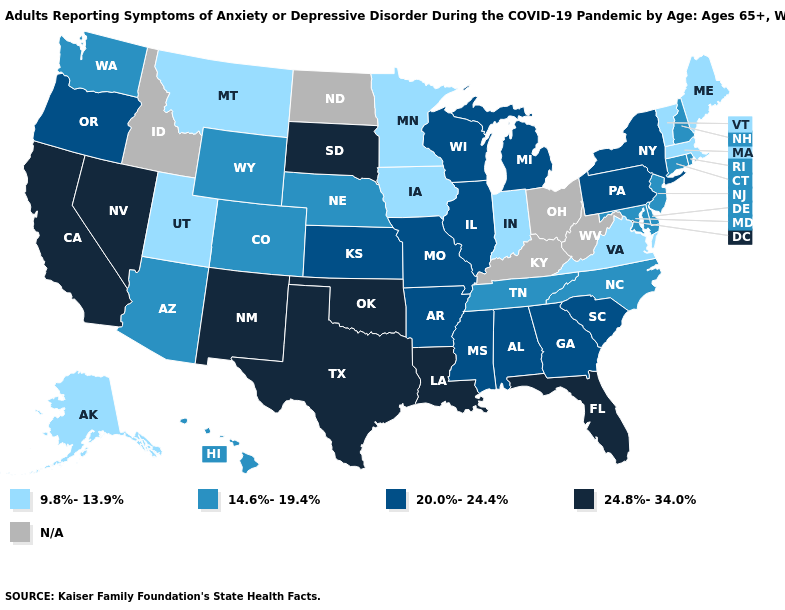What is the value of Georgia?
Quick response, please. 20.0%-24.4%. What is the lowest value in the Northeast?
Short answer required. 9.8%-13.9%. What is the value of Montana?
Concise answer only. 9.8%-13.9%. Which states hav the highest value in the Northeast?
Quick response, please. New York, Pennsylvania. What is the lowest value in the South?
Give a very brief answer. 9.8%-13.9%. How many symbols are there in the legend?
Quick response, please. 5. What is the lowest value in the Northeast?
Be succinct. 9.8%-13.9%. What is the lowest value in the USA?
Keep it brief. 9.8%-13.9%. How many symbols are there in the legend?
Quick response, please. 5. Name the states that have a value in the range 24.8%-34.0%?
Answer briefly. California, Florida, Louisiana, Nevada, New Mexico, Oklahoma, South Dakota, Texas. Name the states that have a value in the range 9.8%-13.9%?
Quick response, please. Alaska, Indiana, Iowa, Maine, Massachusetts, Minnesota, Montana, Utah, Vermont, Virginia. Among the states that border Ohio , does Indiana have the lowest value?
Concise answer only. Yes. What is the value of Vermont?
Keep it brief. 9.8%-13.9%. Name the states that have a value in the range 14.6%-19.4%?
Write a very short answer. Arizona, Colorado, Connecticut, Delaware, Hawaii, Maryland, Nebraska, New Hampshire, New Jersey, North Carolina, Rhode Island, Tennessee, Washington, Wyoming. 